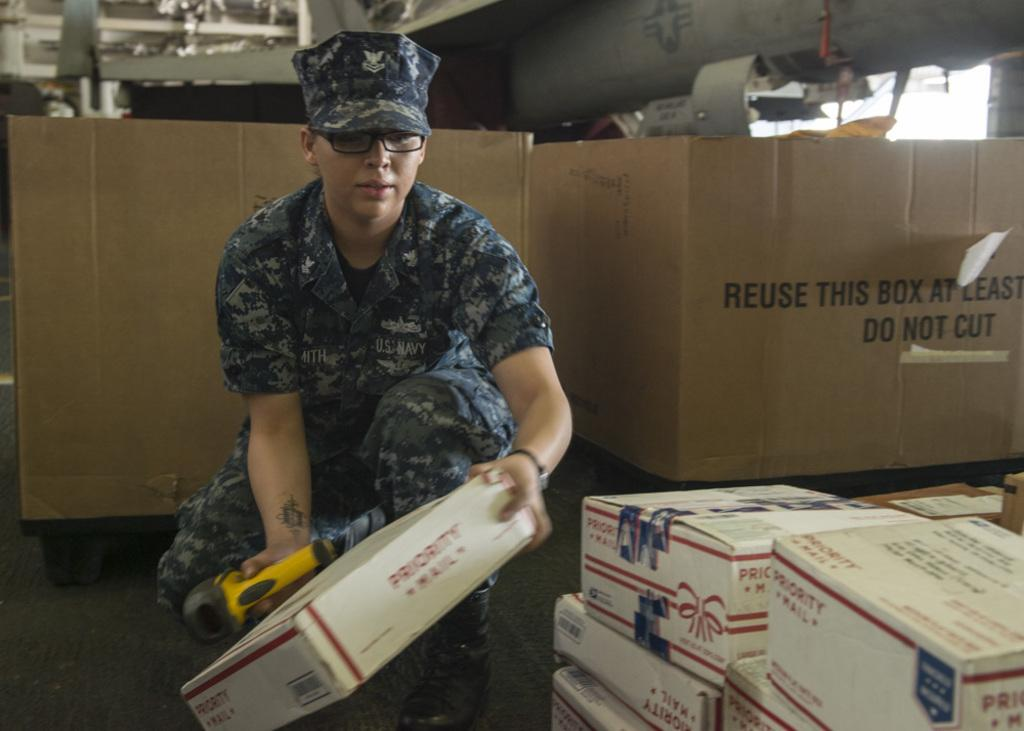<image>
Summarize the visual content of the image. A person in fatigues handling priority mail boxes. 